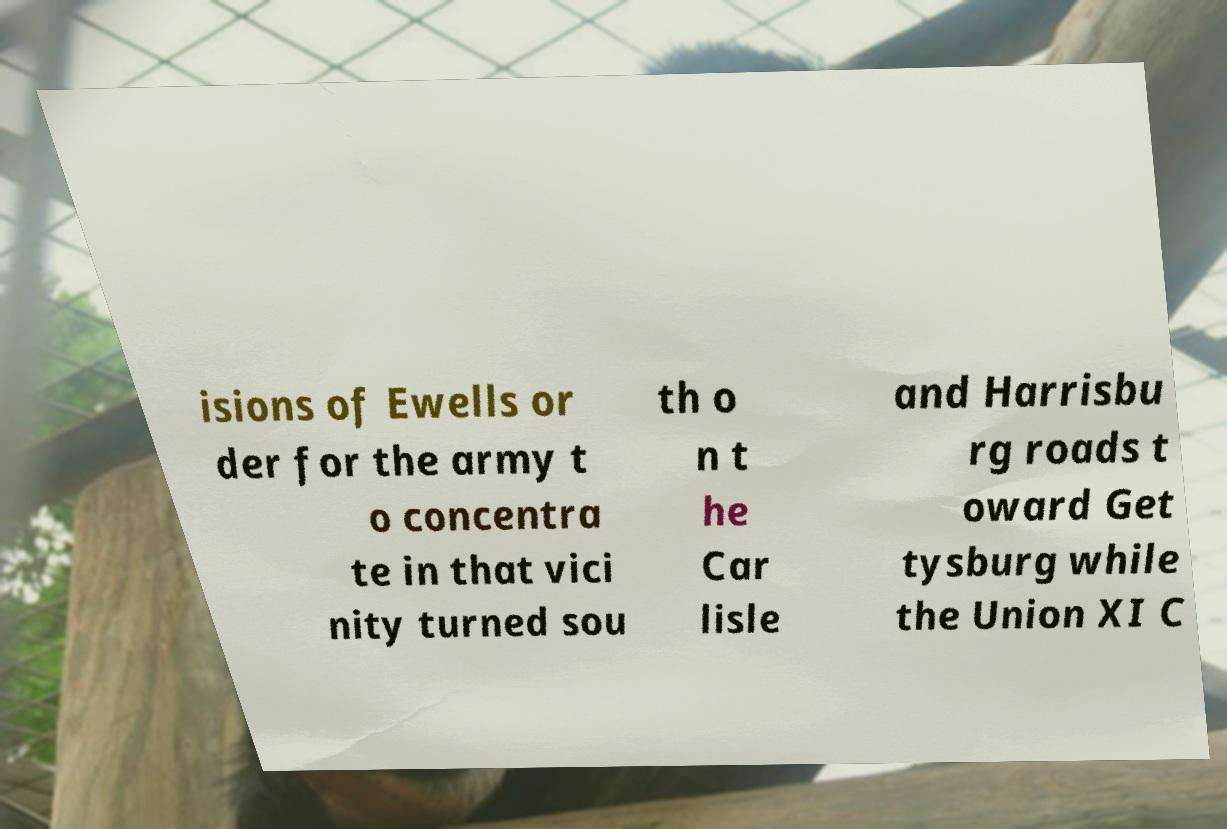Could you assist in decoding the text presented in this image and type it out clearly? isions of Ewells or der for the army t o concentra te in that vici nity turned sou th o n t he Car lisle and Harrisbu rg roads t oward Get tysburg while the Union XI C 